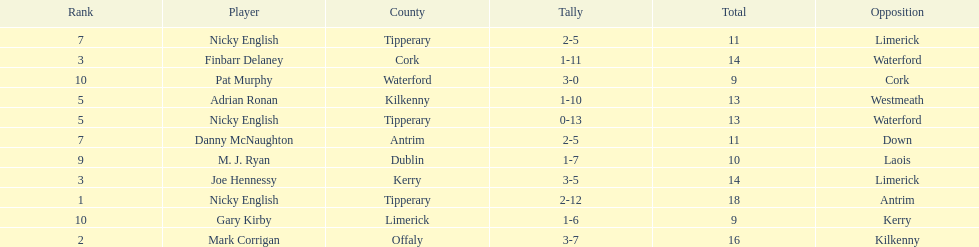What was the mean of the sums of nicky english and mark corrigan? 17. 